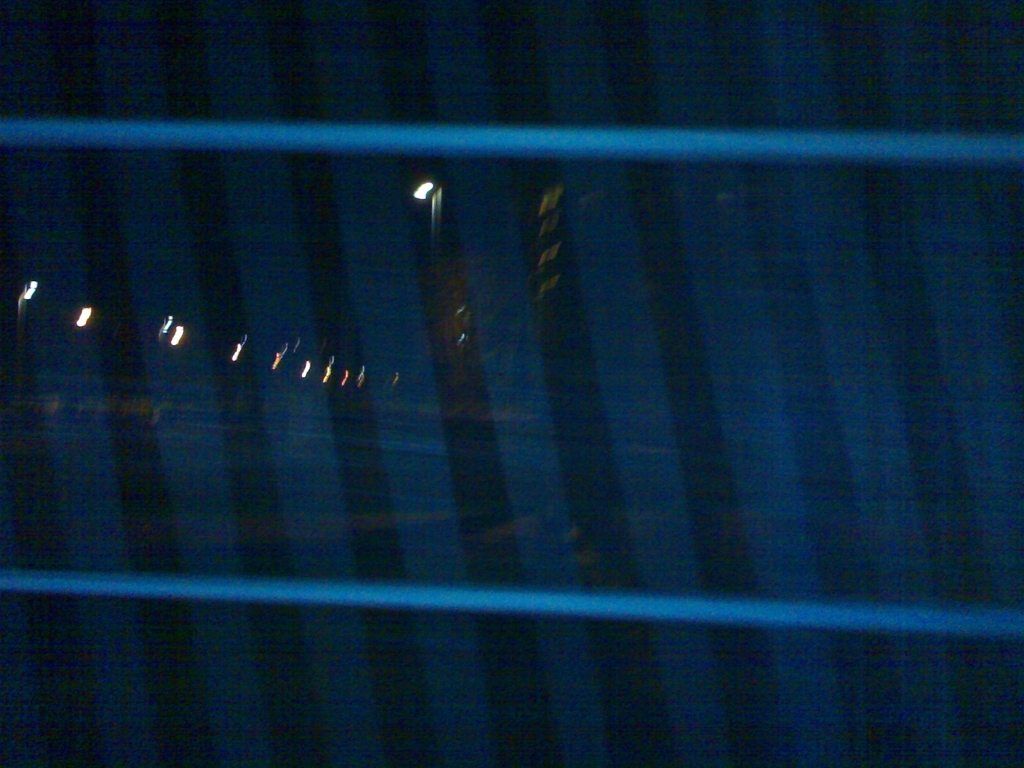What do you imagine is happening beyond the lines that obscure the view? While the specifics are unclear due to the obscured view, one might imagine an urban setting at night where streetlights illuminate a road or pathway. There could be a sense of quiet activity just out of sight, such as cars passing by, pedestrians walking home, or the shuttering of businesses after hours. The obscured lines suggest a vantage point from within, perhaps behind a window or fence, adding a layer of separation between the observer and the outside world. 